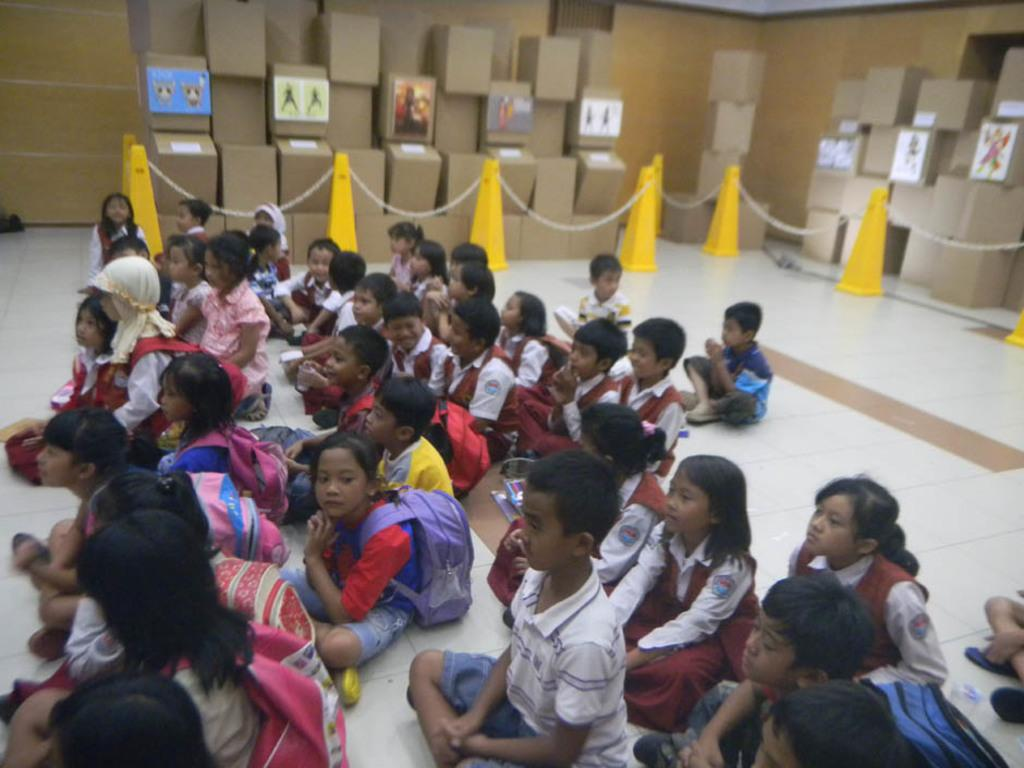What can be seen at the bottom of the image? There are children at the bottom of the image. How are the children dressed? The children are wearing different colored dresses. What position are the children in? The children are sitting on the floor. What can be seen in the background of the image? There are boxes, a fence, and a wall in the background of the image. What type of pear can be seen growing on the fence in the image? There are no pears present in the image, and the fence is not associated with any fruit-bearing plants. 